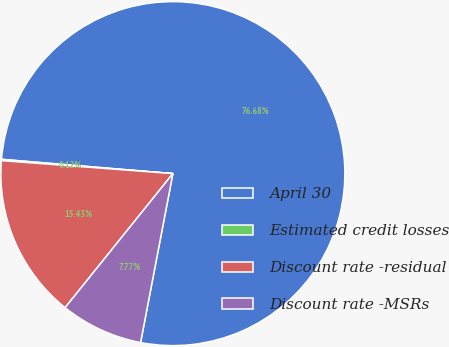Convert chart. <chart><loc_0><loc_0><loc_500><loc_500><pie_chart><fcel>April 30<fcel>Estimated credit losses<fcel>Discount rate -residual<fcel>Discount rate -MSRs<nl><fcel>76.68%<fcel>0.12%<fcel>15.43%<fcel>7.77%<nl></chart> 